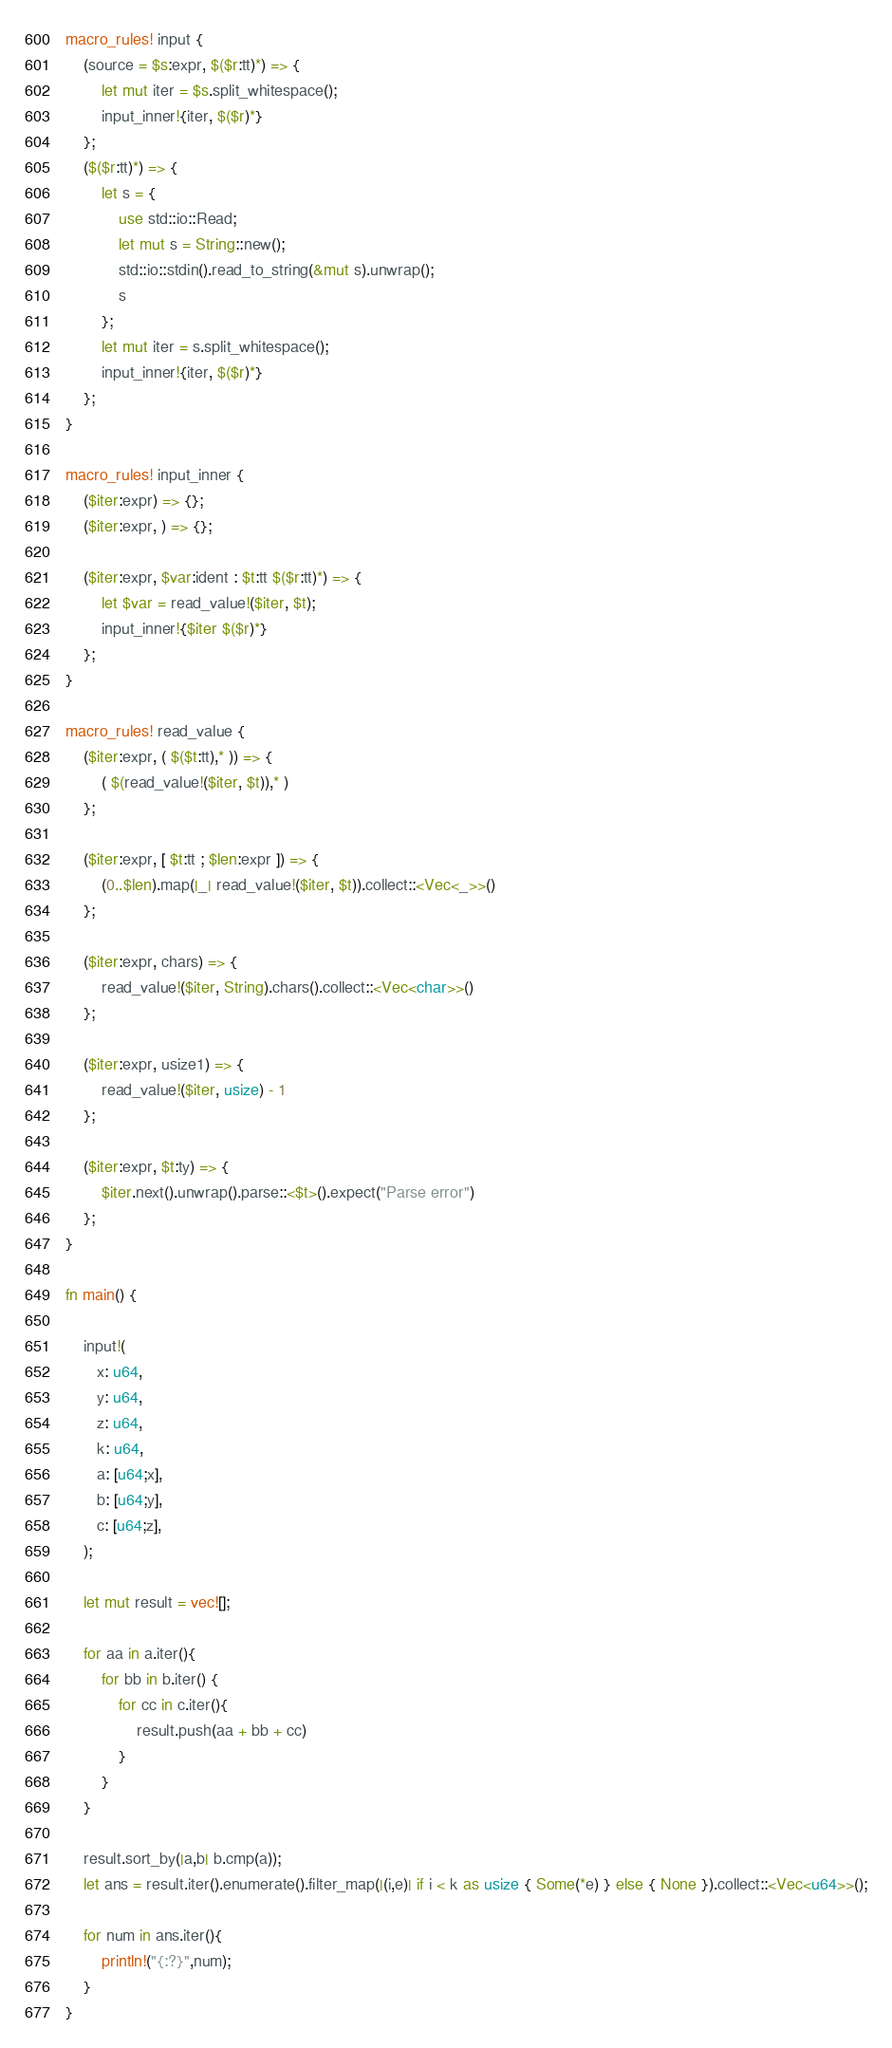Convert code to text. <code><loc_0><loc_0><loc_500><loc_500><_Rust_>macro_rules! input {
    (source = $s:expr, $($r:tt)*) => {
        let mut iter = $s.split_whitespace();
        input_inner!{iter, $($r)*}
    };
    ($($r:tt)*) => {
        let s = {
            use std::io::Read;
            let mut s = String::new();
            std::io::stdin().read_to_string(&mut s).unwrap();
            s
        };
        let mut iter = s.split_whitespace();
        input_inner!{iter, $($r)*}
    };
}

macro_rules! input_inner {
    ($iter:expr) => {};
    ($iter:expr, ) => {};

    ($iter:expr, $var:ident : $t:tt $($r:tt)*) => {
        let $var = read_value!($iter, $t);
        input_inner!{$iter $($r)*}
    };
}

macro_rules! read_value {
    ($iter:expr, ( $($t:tt),* )) => {
        ( $(read_value!($iter, $t)),* )
    };

    ($iter:expr, [ $t:tt ; $len:expr ]) => {
        (0..$len).map(|_| read_value!($iter, $t)).collect::<Vec<_>>()
    };

    ($iter:expr, chars) => {
        read_value!($iter, String).chars().collect::<Vec<char>>()
    };

    ($iter:expr, usize1) => {
        read_value!($iter, usize) - 1
    };

    ($iter:expr, $t:ty) => {
        $iter.next().unwrap().parse::<$t>().expect("Parse error")
    };
}

fn main() {

    input!(
       x: u64,
       y: u64,
       z: u64,
       k: u64,
       a: [u64;x],
       b: [u64;y],
       c: [u64;z],
    );

    let mut result = vec![];

    for aa in a.iter(){
        for bb in b.iter() {
            for cc in c.iter(){
                result.push(aa + bb + cc)
            }
        }
    }
    
    result.sort_by(|a,b| b.cmp(a));
    let ans = result.iter().enumerate().filter_map(|(i,e)| if i < k as usize { Some(*e) } else { None }).collect::<Vec<u64>>();

    for num in ans.iter(){
        println!("{:?}",num);
    }
}
</code> 